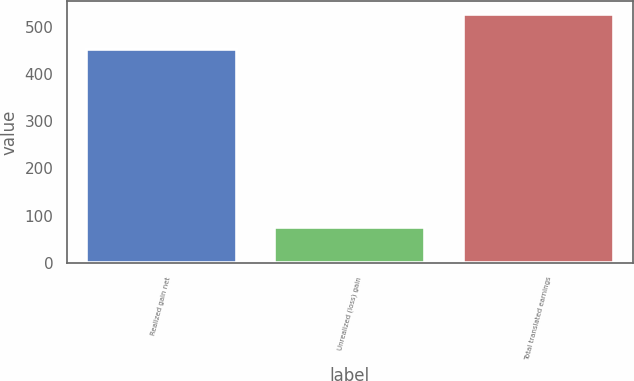<chart> <loc_0><loc_0><loc_500><loc_500><bar_chart><fcel>Realized gain net<fcel>Unrealized (loss) gain<fcel>Total translated earnings<nl><fcel>452<fcel>76<fcel>528<nl></chart> 